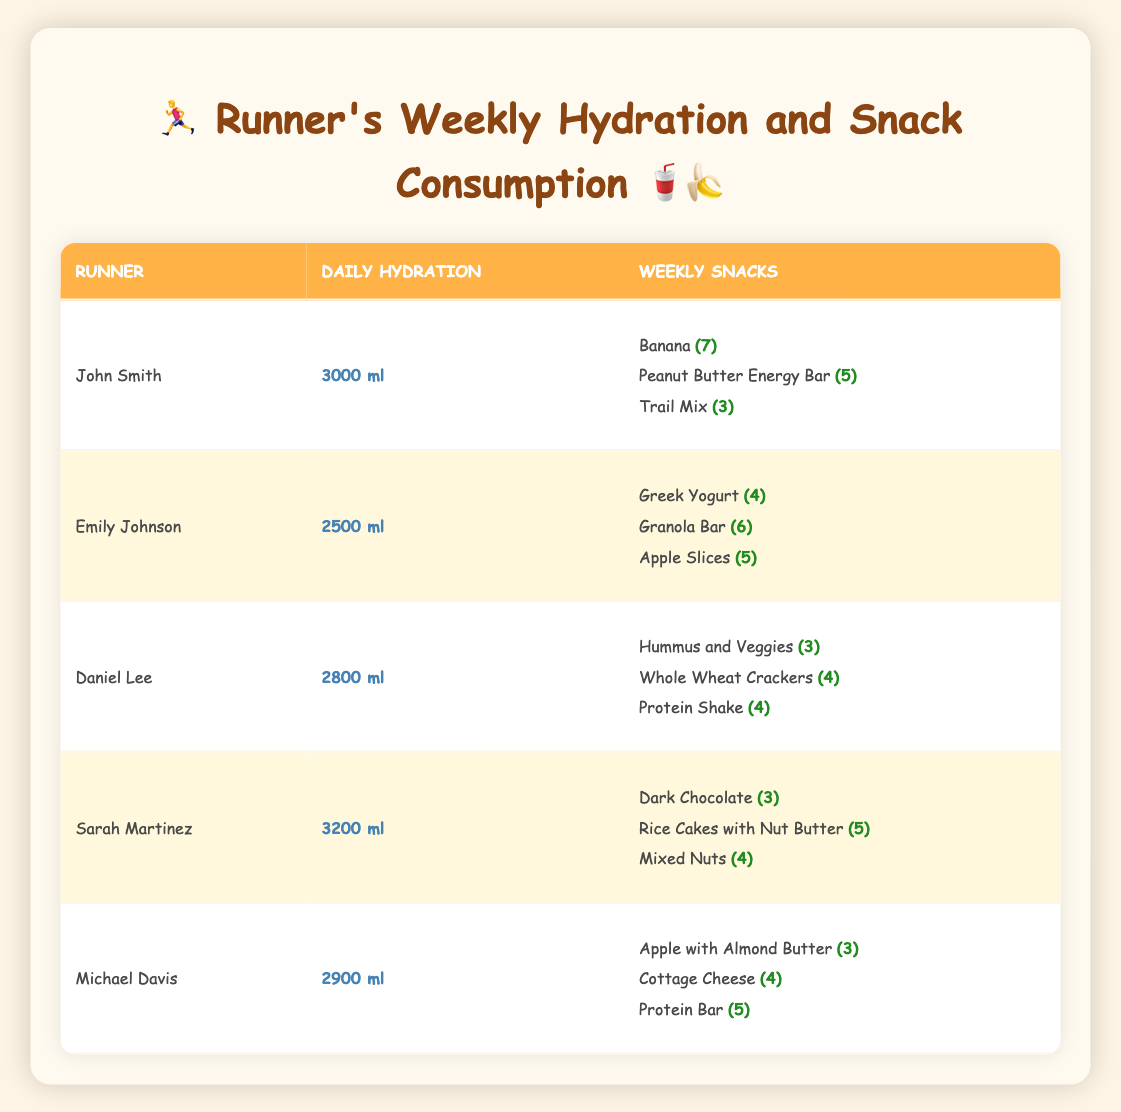What is the daily hydration amount for Sarah Martinez? Sarah Martinez has her daily hydration listed as 3200 ml in the table.
Answer: 3200 ml Which runner consumes the least amount of hydration per day? Emily Johnson consumes 2500 ml per day, which is lower than all other runners listed.
Answer: Emily Johnson How many total snacks does John Smith consume in a week? John Smith has 7 bananas, 5 energy bars, and 3 trail mixes. Summing these, 7 + 5 + 3 = 15 total snacks.
Answer: 15 snacks What snack does Daniel Lee have the highest quantity of? Daniel Lee has 4 Whole Wheat Crackers, the highest among his snacks compared to 3 Hummus and Veggies and 4 Protein Shakes.
Answer: Whole Wheat Crackers Is Sarah Martinez's daily hydration higher than Michael Davis's? Sarah Martinez drinks 3200 ml while Michael Davis drinks 2900 ml. Since 3200 ml is greater than 2900 ml, the statement is true.
Answer: Yes What is the average daily hydration among all the runners? The daily hydration amounts are 3000, 2500, 2800, 3200, and 2900 ml. The sum is 3000 + 2500 + 2800 + 3200 + 2900 = 14400 ml. There are 5 runners, so the average is 14400 ml / 5 = 2880 ml.
Answer: 2880 ml Which snack is most commonly consumed by Emily Johnson and how many? Emily Johnson has 6 Granola Bars, which is the highest quantity among her snacks compared to Greek Yogurt (4) and Apple Slices (5).
Answer: Granola Bar (6) How many snacks does Sarah Martinez have in total? Sarah Martinez has 3 Dark Chocolates, 5 Rice Cakes with Nut Butter, and 4 Mixed Nuts. Summing these gives 3 + 5 + 4 = 12 snacks total.
Answer: 12 snacks Is Daniel Lee's total weekly hydration greater than all other runners combined? Daniel Lee's daily hydration is 2800 ml. For 7 days, that's 2800 ml x 7 = 19600 ml. Checking others: John = 21000 ml, Emily = 17500 ml, Sarah = 22400 ml, Michael = 20300 ml. 19600 ml is less than all other totals combined. So, the statement is false.
Answer: No What is the total amount of trail mix and peanut butter energy bars John's consuming in a week? John consumes 3 Trail Mix and 5 Peanut Butter Energy Bars. Over 7 days, he consumes 3 x 7 = 21 Trail Mix and 5 x 7 = 35 Peanut Butter Energy Bars. The total is 21 + 35 = 56 snacks a week.
Answer: 56 snacks 